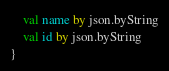Convert code to text. <code><loc_0><loc_0><loc_500><loc_500><_Kotlin_>    val name by json.byString
    val id by json.byString
}
</code> 